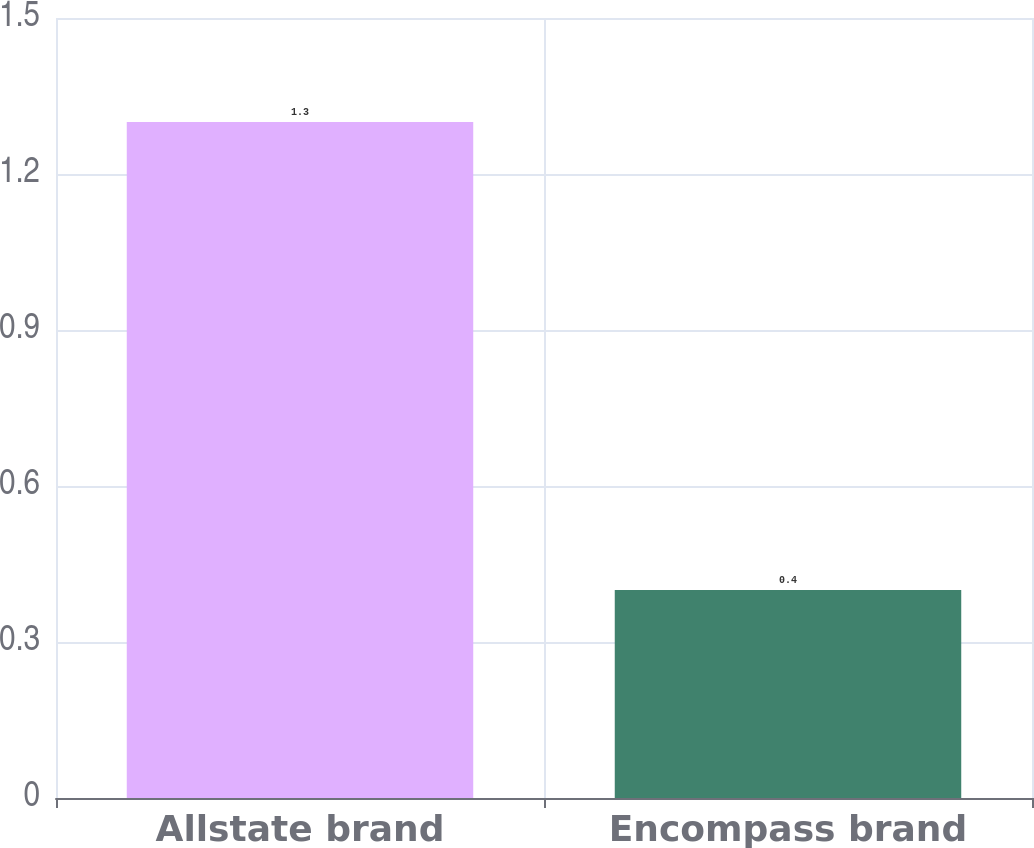<chart> <loc_0><loc_0><loc_500><loc_500><bar_chart><fcel>Allstate brand<fcel>Encompass brand<nl><fcel>1.3<fcel>0.4<nl></chart> 